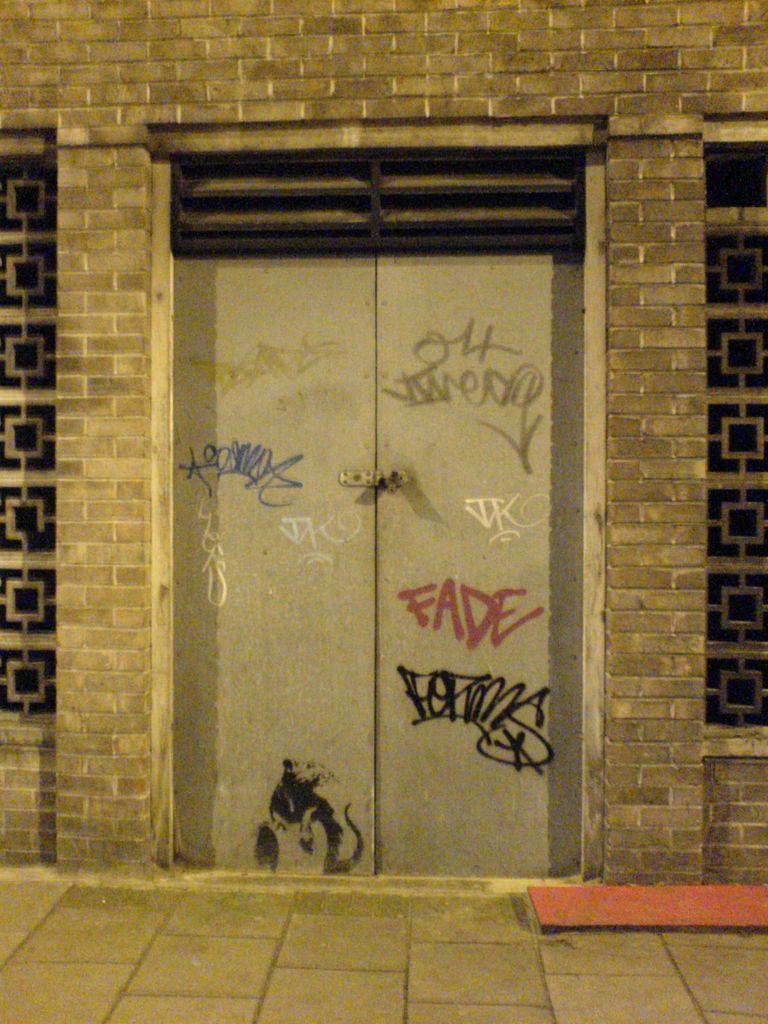How would you summarize this image in a sentence or two? In this image there is are windows and door of a building, there is some text on the door. 